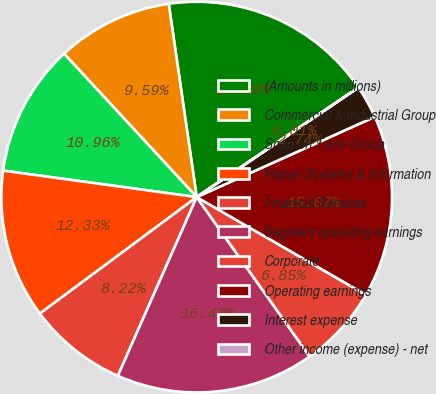Convert chart. <chart><loc_0><loc_0><loc_500><loc_500><pie_chart><fcel>(Amounts in millions)<fcel>Commercial & Industrial Group<fcel>Snap-on Tools Group<fcel>Repair Systems & Information<fcel>Financial Services<fcel>Segment operating earnings<fcel>Corporate<fcel>Operating earnings<fcel>Interest expense<fcel>Other income (expense) - net<nl><fcel>17.8%<fcel>9.59%<fcel>10.96%<fcel>12.33%<fcel>8.22%<fcel>16.43%<fcel>6.85%<fcel>15.07%<fcel>2.74%<fcel>0.01%<nl></chart> 